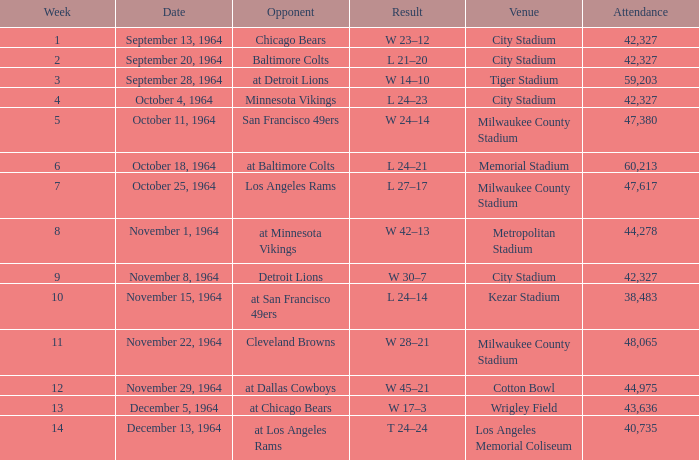What is the average week of the game on November 22, 1964 attended by 48,065? None. 